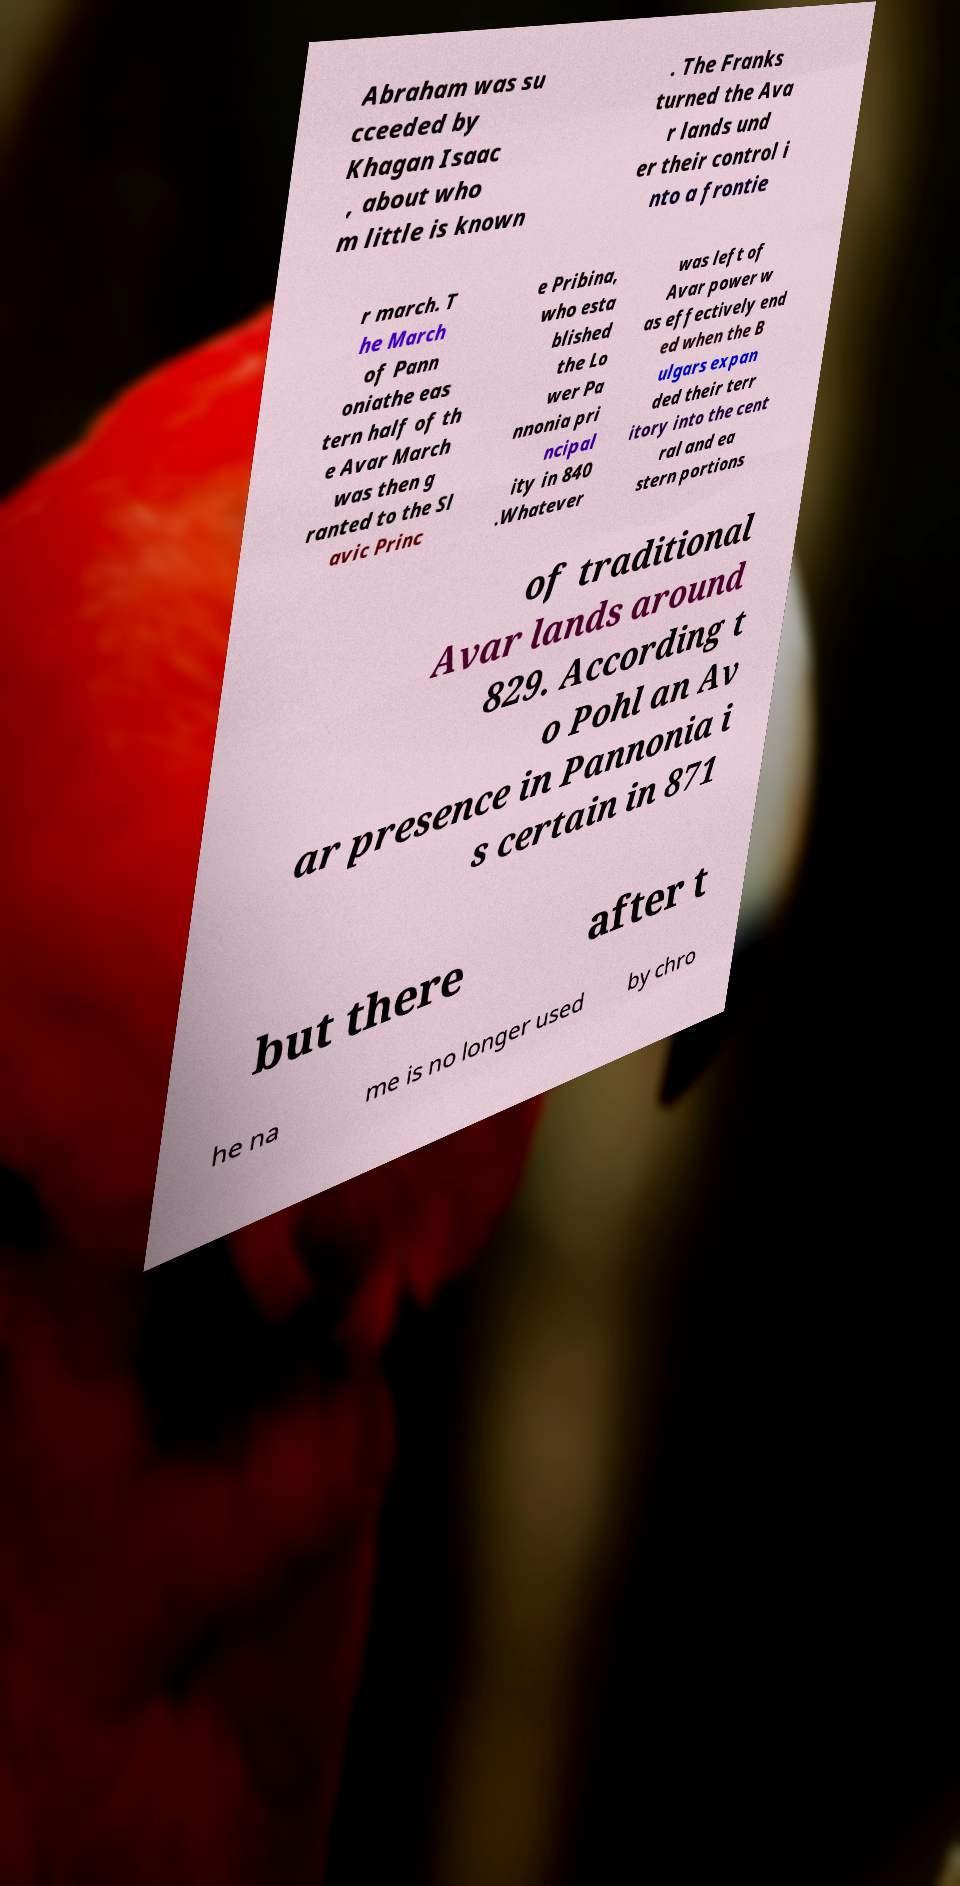Please identify and transcribe the text found in this image. Abraham was su cceeded by Khagan Isaac , about who m little is known . The Franks turned the Ava r lands und er their control i nto a frontie r march. T he March of Pann oniathe eas tern half of th e Avar March was then g ranted to the Sl avic Princ e Pribina, who esta blished the Lo wer Pa nnonia pri ncipal ity in 840 .Whatever was left of Avar power w as effectively end ed when the B ulgars expan ded their terr itory into the cent ral and ea stern portions of traditional Avar lands around 829. According t o Pohl an Av ar presence in Pannonia i s certain in 871 but there after t he na me is no longer used by chro 